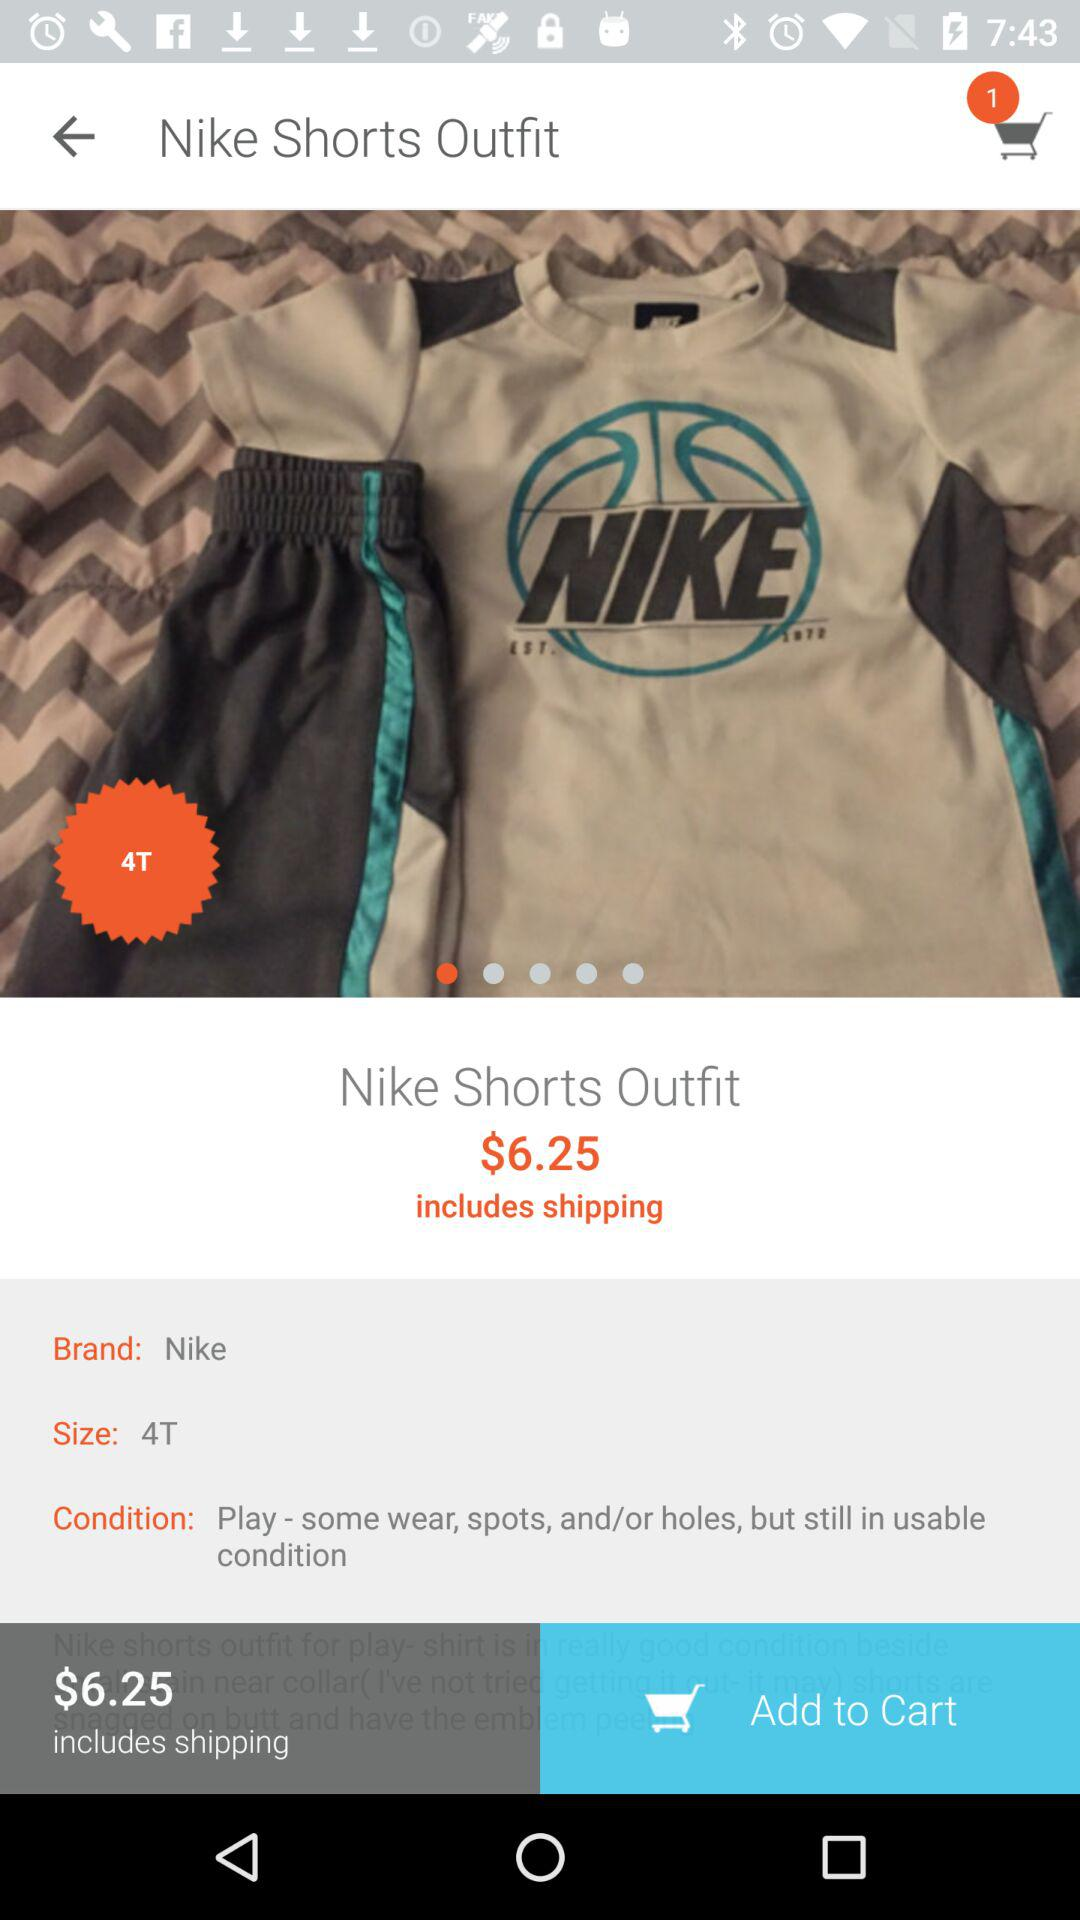What is the condition of the Nike Shorts Outfit?
Answer the question using a single word or phrase. Play - some wear, spots, and/or holes, but still in usable condition 